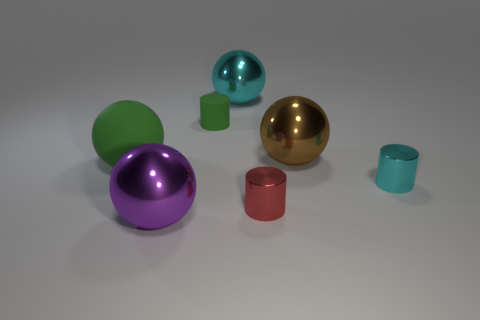Add 1 small rubber cubes. How many objects exist? 8 Subtract all green balls. How many balls are left? 3 Subtract all purple spheres. How many spheres are left? 3 Subtract 1 cylinders. How many cylinders are left? 2 Subtract 0 purple cylinders. How many objects are left? 7 Subtract all balls. How many objects are left? 3 Subtract all red cylinders. Subtract all brown blocks. How many cylinders are left? 2 Subtract all gray spheres. Subtract all small red metal cylinders. How many objects are left? 6 Add 6 green cylinders. How many green cylinders are left? 7 Add 2 large rubber spheres. How many large rubber spheres exist? 3 